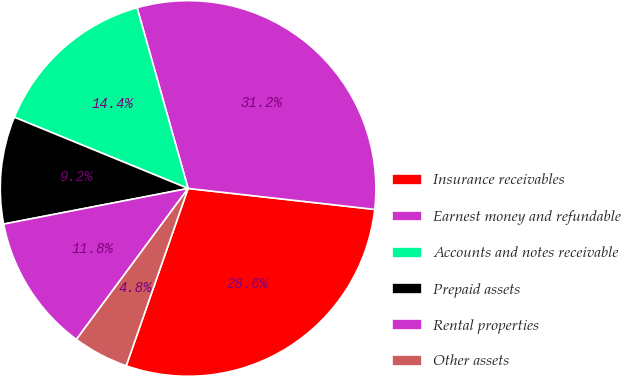Convert chart. <chart><loc_0><loc_0><loc_500><loc_500><pie_chart><fcel>Insurance receivables<fcel>Earnest money and refundable<fcel>Accounts and notes receivable<fcel>Prepaid assets<fcel>Rental properties<fcel>Other assets<nl><fcel>28.56%<fcel>31.16%<fcel>14.43%<fcel>9.23%<fcel>11.83%<fcel>4.79%<nl></chart> 